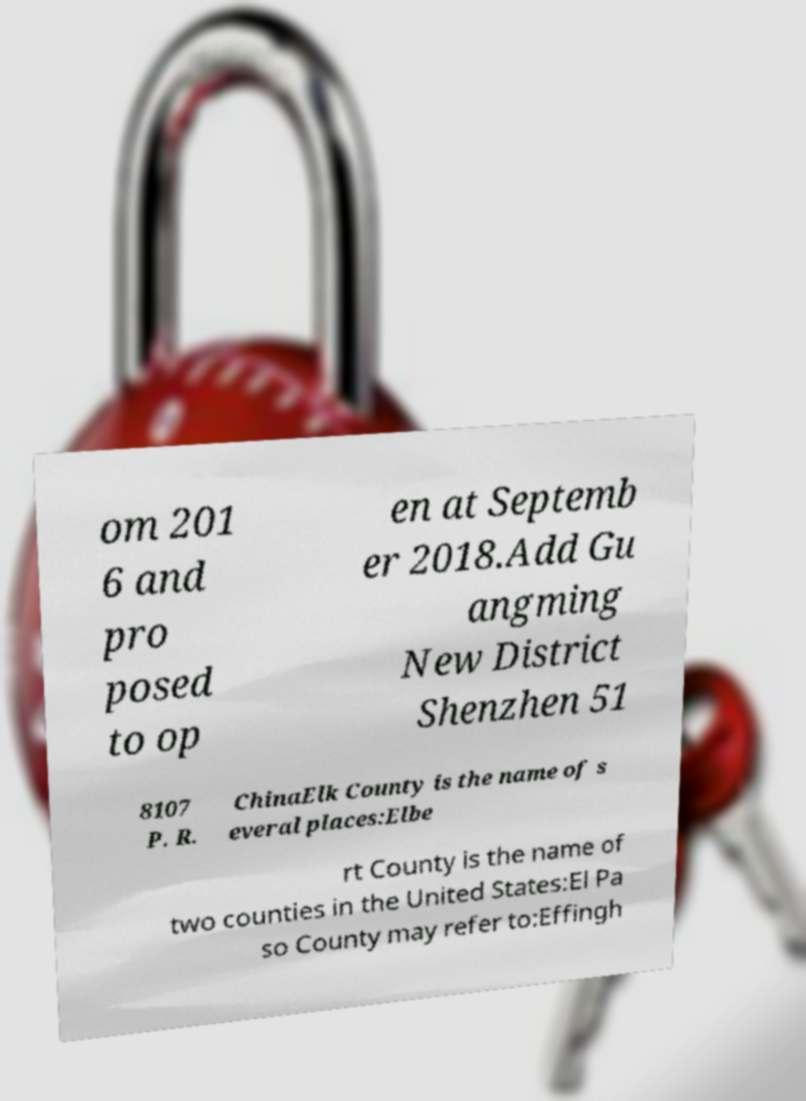Can you read and provide the text displayed in the image?This photo seems to have some interesting text. Can you extract and type it out for me? om 201 6 and pro posed to op en at Septemb er 2018.Add Gu angming New District Shenzhen 51 8107 P. R. ChinaElk County is the name of s everal places:Elbe rt County is the name of two counties in the United States:El Pa so County may refer to:Effingh 